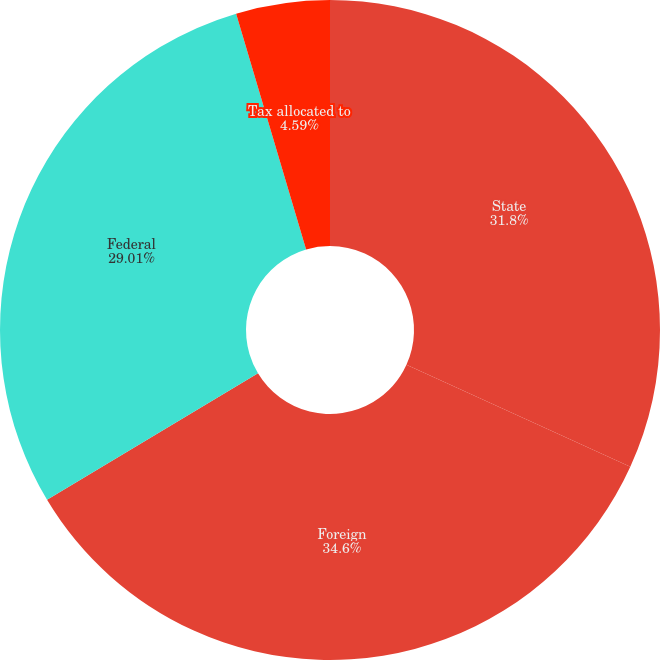Convert chart. <chart><loc_0><loc_0><loc_500><loc_500><pie_chart><fcel>State<fcel>Foreign<fcel>Federal<fcel>Tax allocated to<nl><fcel>31.8%<fcel>34.59%<fcel>29.01%<fcel>4.59%<nl></chart> 